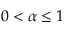<formula> <loc_0><loc_0><loc_500><loc_500>0 < \alpha \leq 1</formula> 